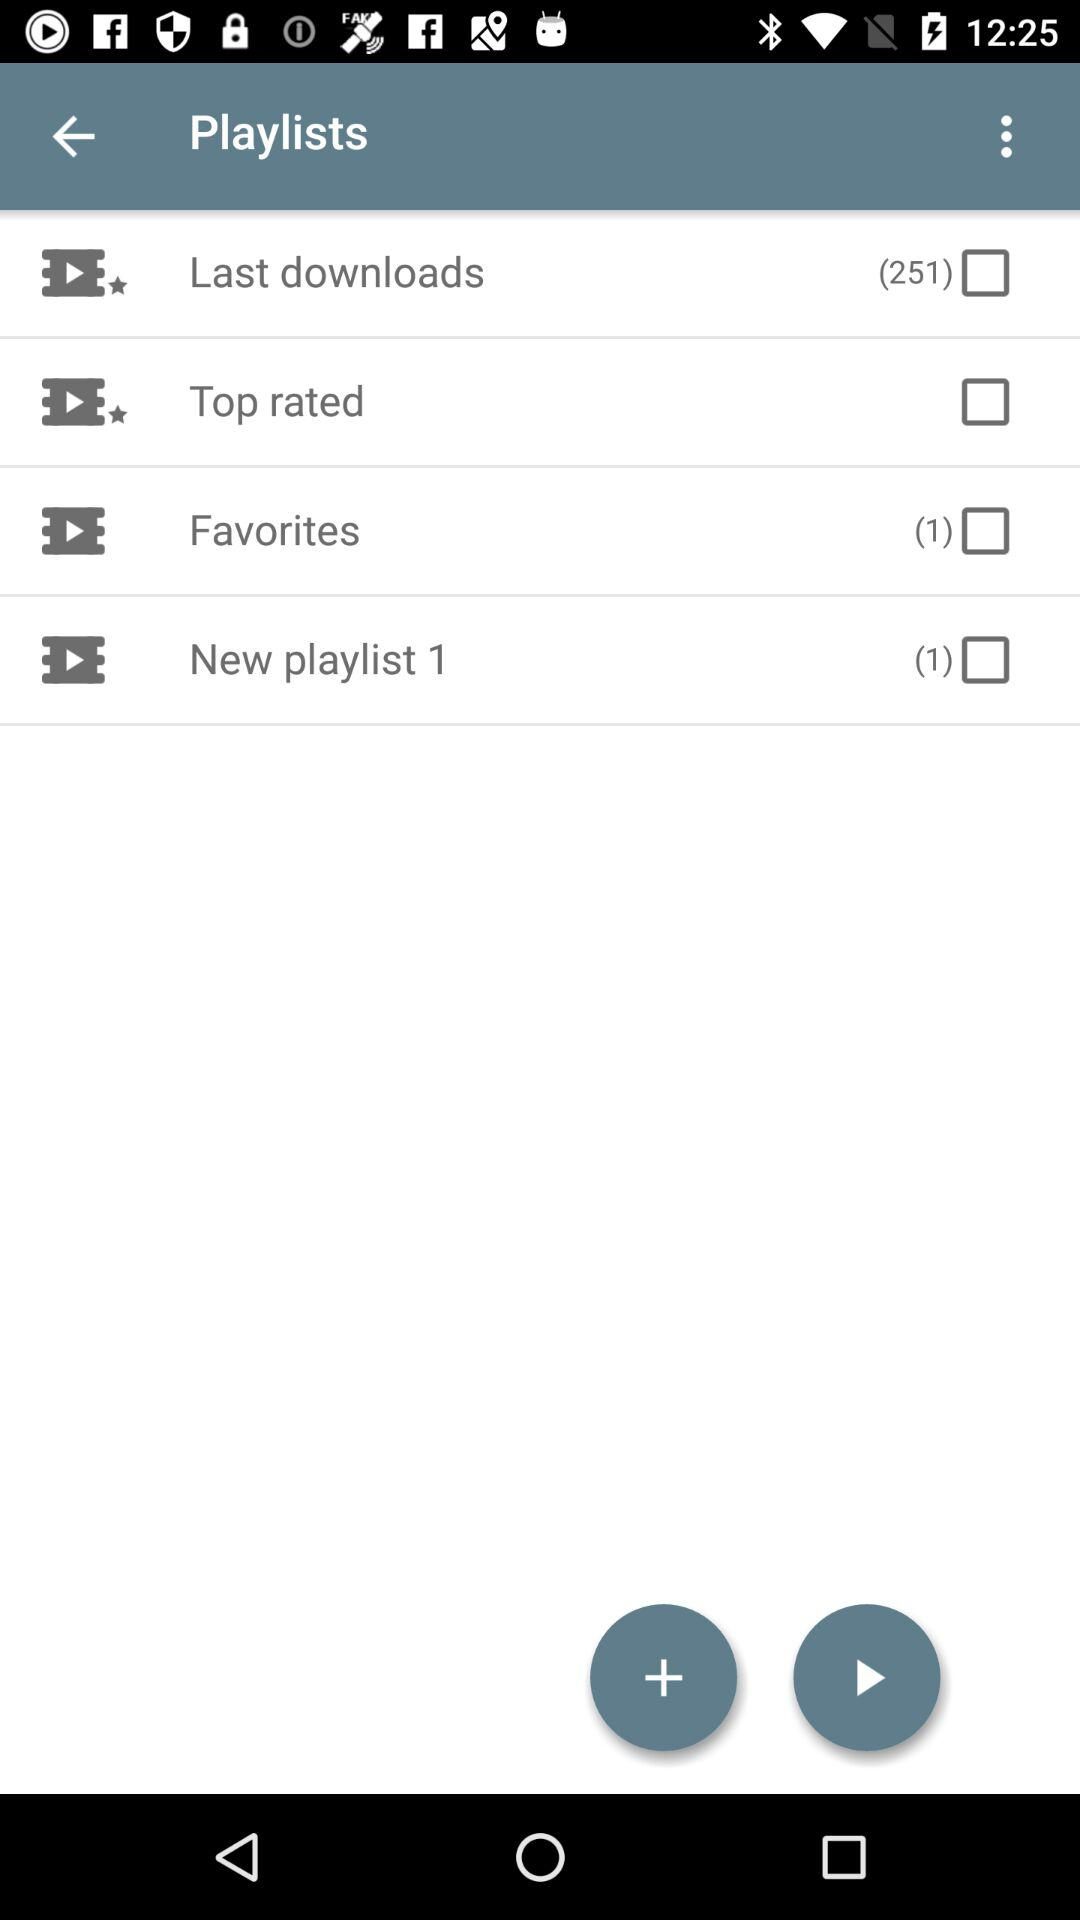How many "Last downloads" are there? There are 251 "Last downloads". 